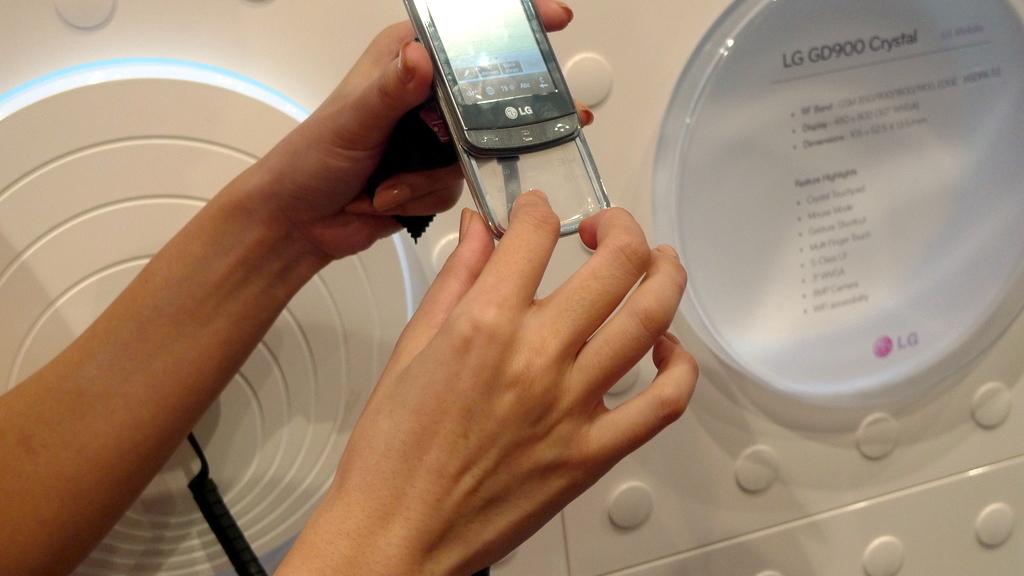What brand is this phone?
Your answer should be compact. Lg. What model phone is this?
Your response must be concise. Lg gd900 crystal. 